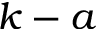<formula> <loc_0><loc_0><loc_500><loc_500>k - a</formula> 